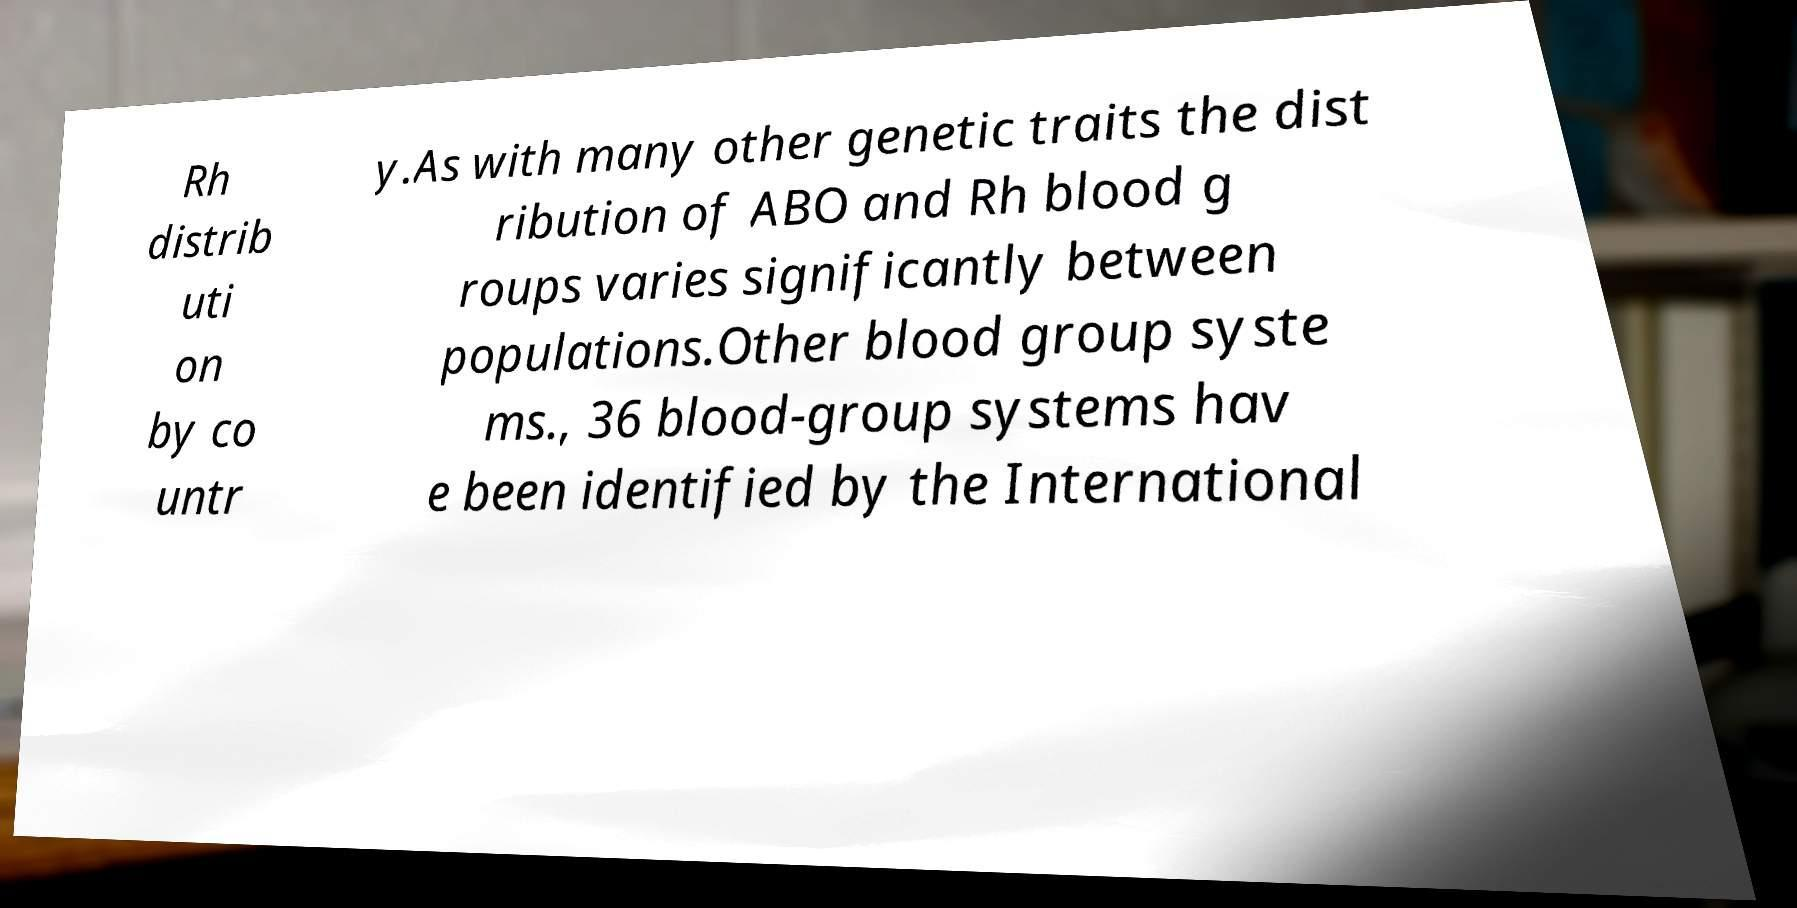I need the written content from this picture converted into text. Can you do that? Rh distrib uti on by co untr y.As with many other genetic traits the dist ribution of ABO and Rh blood g roups varies significantly between populations.Other blood group syste ms., 36 blood-group systems hav e been identified by the International 